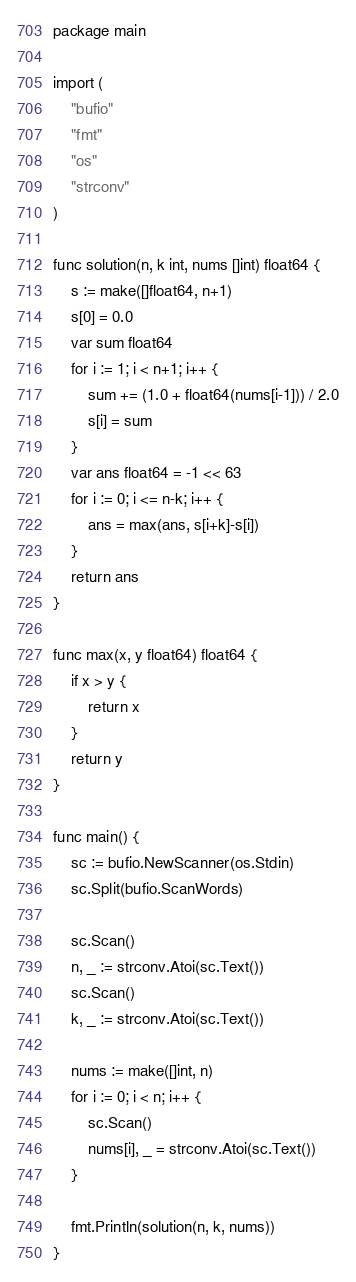<code> <loc_0><loc_0><loc_500><loc_500><_Go_>package main

import (
	"bufio"
	"fmt"
	"os"
	"strconv"
)

func solution(n, k int, nums []int) float64 {
	s := make([]float64, n+1)
	s[0] = 0.0
	var sum float64
	for i := 1; i < n+1; i++ {
		sum += (1.0 + float64(nums[i-1])) / 2.0
		s[i] = sum
	}
	var ans float64 = -1 << 63
	for i := 0; i <= n-k; i++ {
		ans = max(ans, s[i+k]-s[i])
	}
	return ans
}

func max(x, y float64) float64 {
	if x > y {
		return x
	}
	return y
}

func main() {
	sc := bufio.NewScanner(os.Stdin)
	sc.Split(bufio.ScanWords)

	sc.Scan()
	n, _ := strconv.Atoi(sc.Text())
	sc.Scan()
	k, _ := strconv.Atoi(sc.Text())

	nums := make([]int, n)
	for i := 0; i < n; i++ {
		sc.Scan()
		nums[i], _ = strconv.Atoi(sc.Text())
	}

	fmt.Println(solution(n, k, nums))
}
</code> 